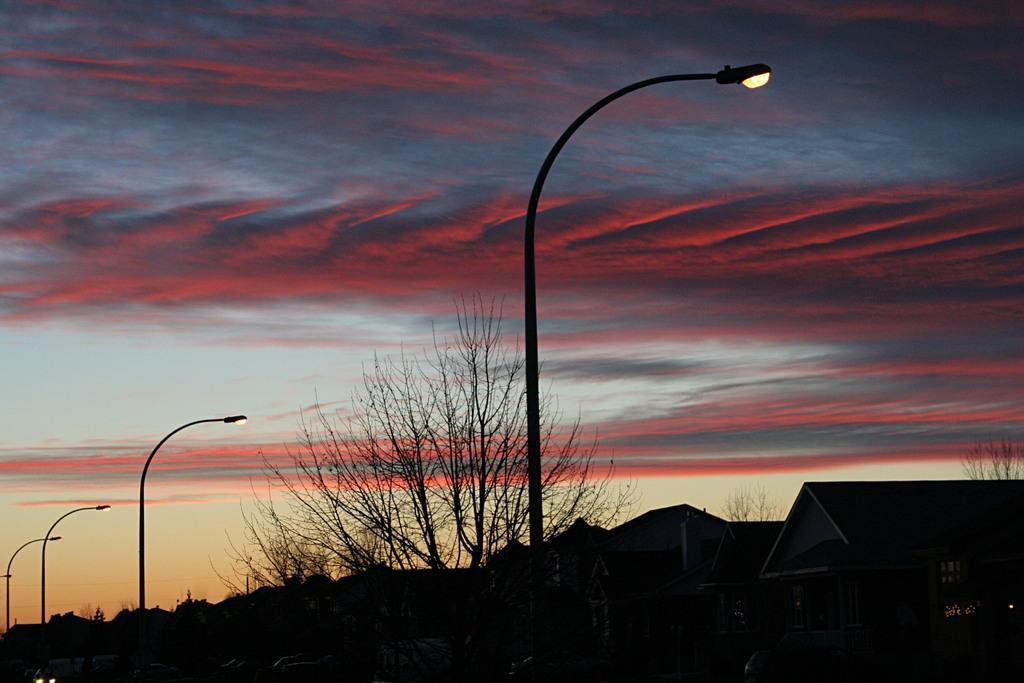Please provide a concise description of this image. In this picture we can see there are poles with lights, trees, houses and a sky. 